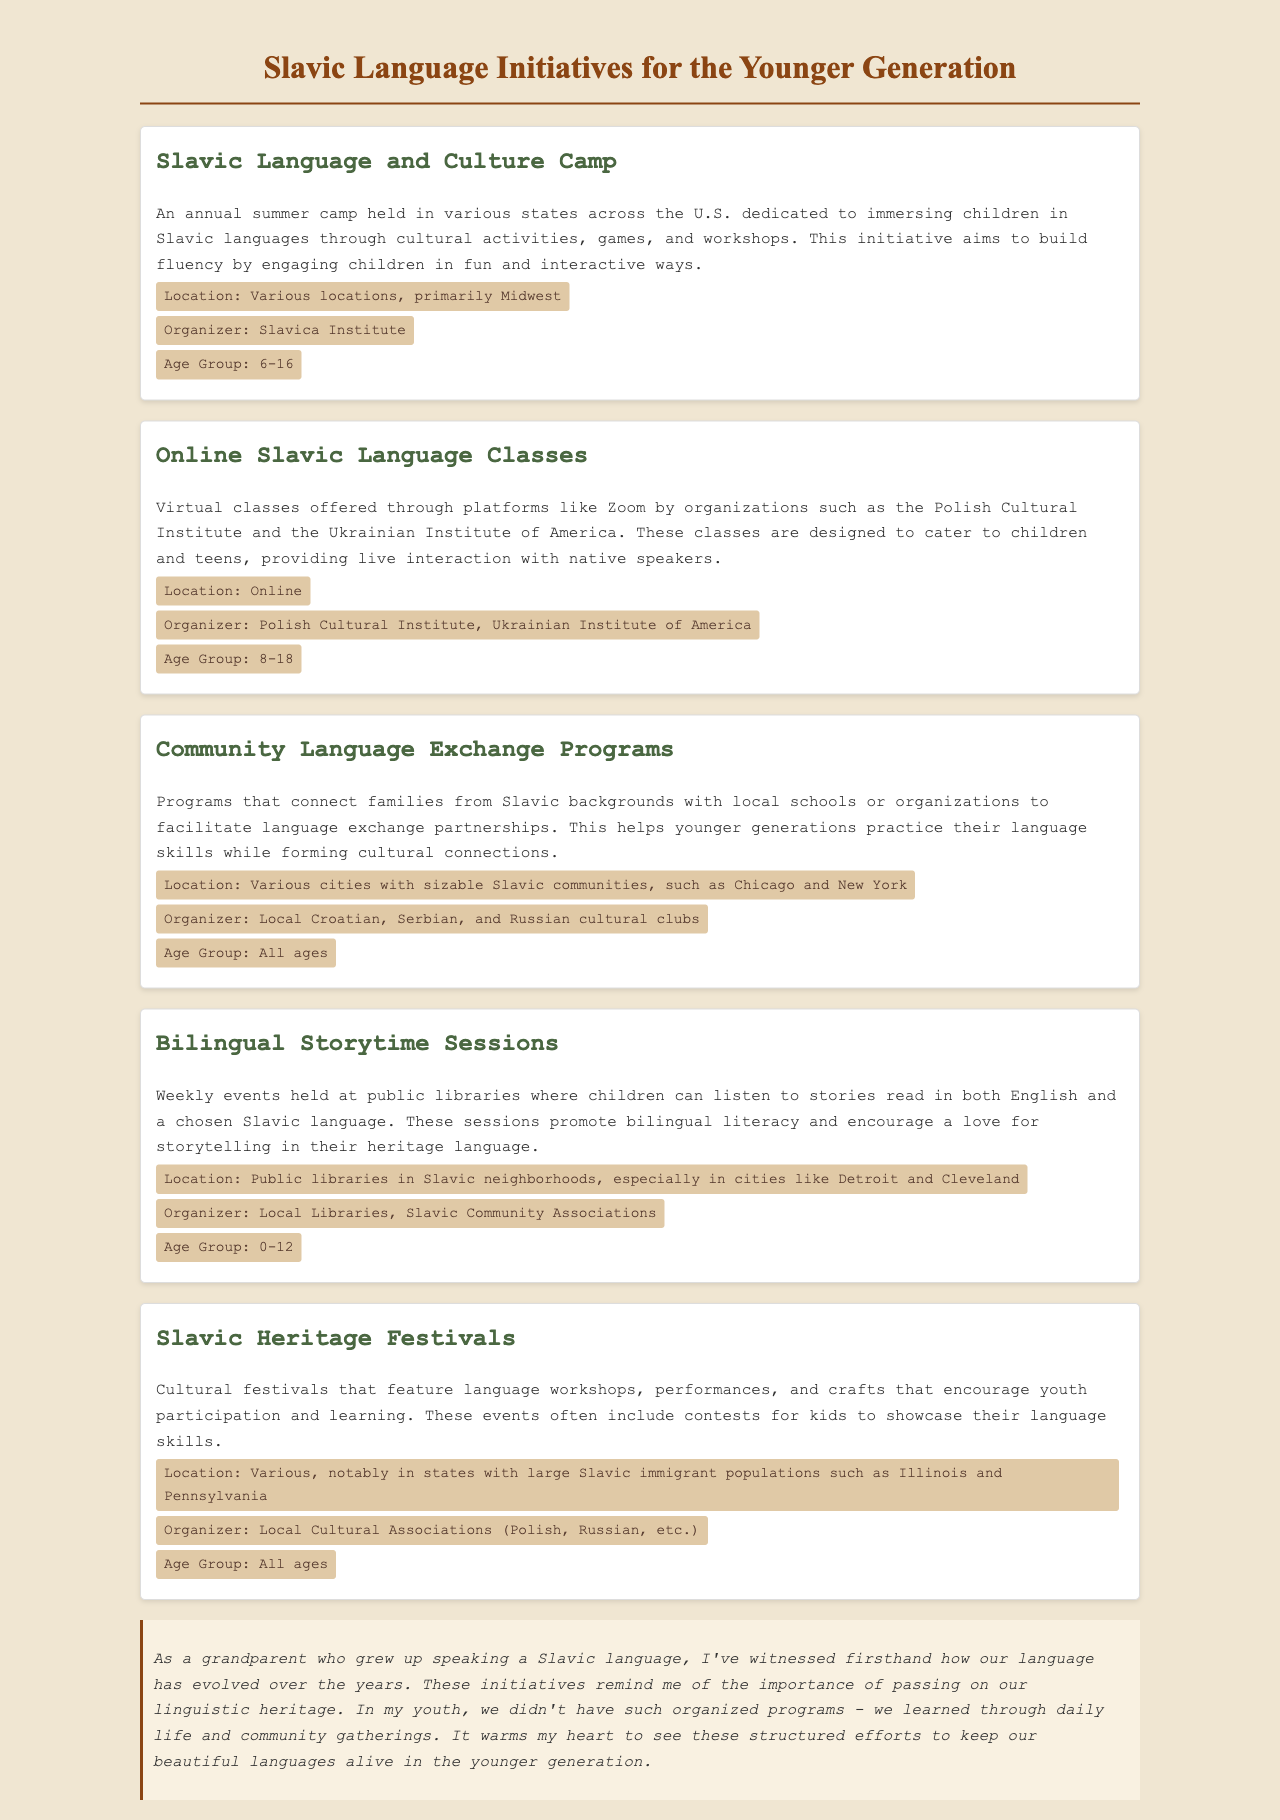What is the name of the language camp? The document specifically mentions an annual summer camp dedicated to Slavic languages, termed "Slavic Language and Culture Camp."
Answer: Slavic Language and Culture Camp Who organizes the online classes? The document lists the organizations responsible for the online classes, which are the Polish Cultural Institute and the Ukrainian Institute of America.
Answer: Polish Cultural Institute, Ukrainian Institute of America What age group is targeted by the Bilingual Storytime Sessions? According to the document, Bilingual Storytime Sessions are designed for children aged 0-12 years.
Answer: 0-12 Where are Slavic Heritage Festivals primarily located? The festivals are mentioned to take place notably in states with large Slavic immigrant populations, specifically in Illinois and Pennsylvania.
Answer: Illinois and Pennsylvania What is the main goal of the Community Language Exchange Programs? The document states that these programs aim to facilitate language exchange partnerships to help younger generations practice their language skills.
Answer: Practice language skills How do the initiatives aim to engage children? The initiatives aim to engage children through interactive and fun activities such as games, workshops, and cultural events.
Answer: Interactive and fun activities What is a unique feature of the Slavic Language and Culture Camp? The camp is characterized by immersing children in Slavic languages through cultural activities, games, and workshops.
Answer: Cultural activities, games, and workshops What types of events are included in the Slavic Heritage Festivals? The festivals include workshops, performances, and contests designed to encourage youth participation and language learning.
Answer: Workshops, performances, and contests Which cultural clubs organize the Community Language Exchange Programs? The document indicates that local Croatian, Serbian, and Russian cultural clubs are responsible for organizing these programs.
Answer: Local Croatian, Serbian, and Russian cultural clubs 